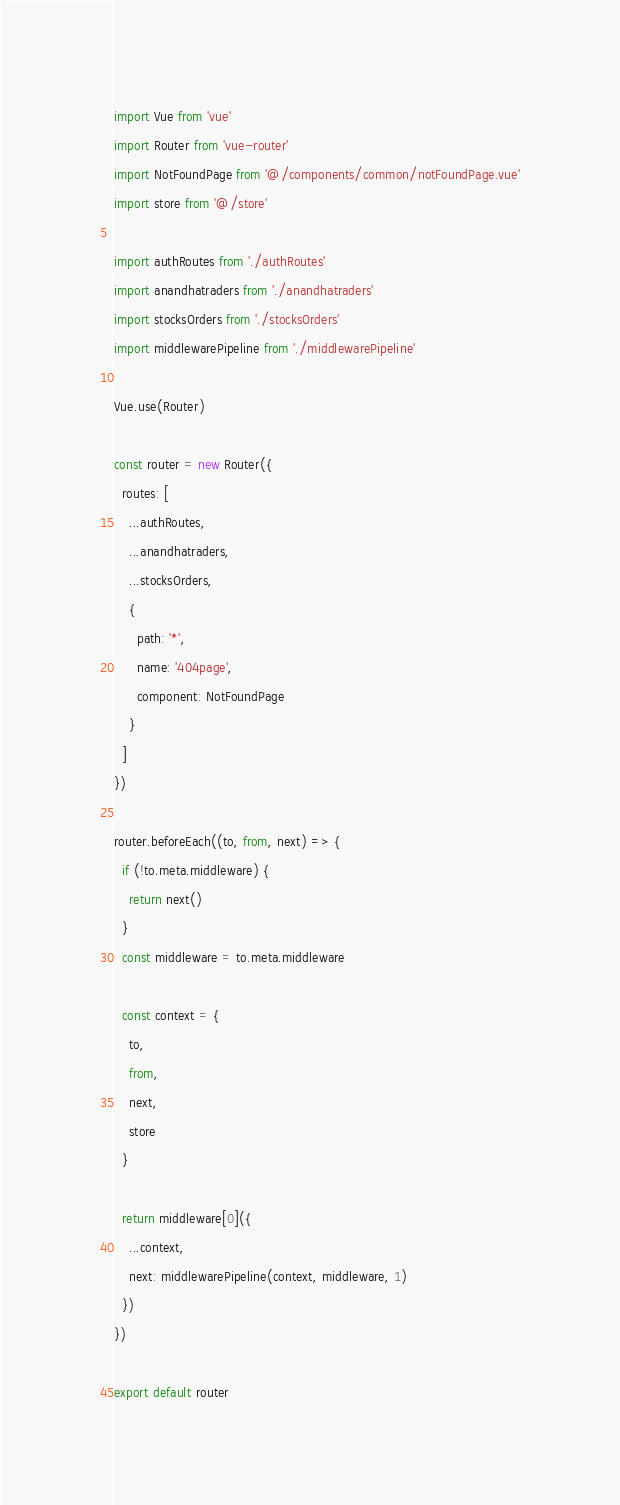<code> <loc_0><loc_0><loc_500><loc_500><_JavaScript_>import Vue from 'vue'
import Router from 'vue-router'
import NotFoundPage from '@/components/common/notFoundPage.vue'
import store from '@/store'

import authRoutes from './authRoutes'
import anandhatraders from './anandhatraders'
import stocksOrders from './stocksOrders'
import middlewarePipeline from './middlewarePipeline'

Vue.use(Router)

const router = new Router({
  routes: [
    ...authRoutes,
    ...anandhatraders,
    ...stocksOrders,
    {
      path: '*',
      name: '404page',
      component: NotFoundPage
    }
  ]
})

router.beforeEach((to, from, next) => {
  if (!to.meta.middleware) {
    return next()
  }
  const middleware = to.meta.middleware

  const context = {
    to,
    from,
    next,
    store
  }

  return middleware[0]({
    ...context,
    next: middlewarePipeline(context, middleware, 1)
  })
})

export default router
</code> 